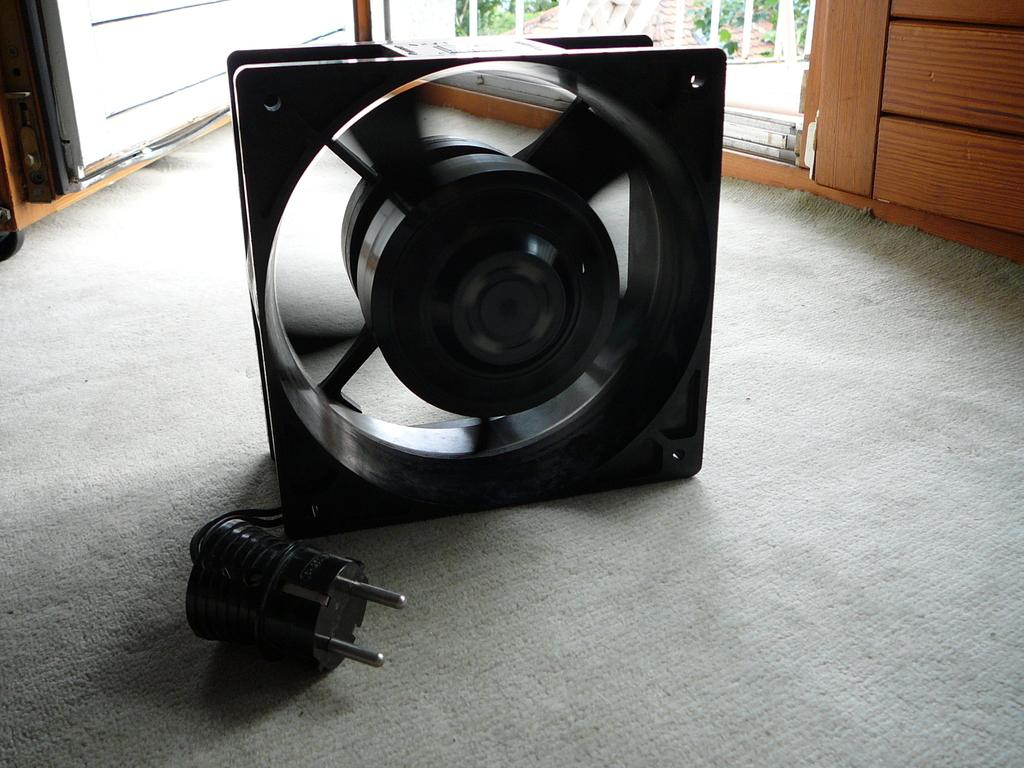What type of appliance is present in the image? There is a fan in the image. What color is the fan? The fan is black in color. Does the fan have any controls? Yes, the fan has a switch. What type of door can be seen in the image? There is a wooden door in the image. Is the wooden door opened or closed? The wooden door is opened. How many cats are sitting on the fan in the image? There are no cats present in the image; it only features a fan and a wooden door. What type of shirt is the fan wearing in the image? Fans do not wear shirts, as they are inanimate objects. 